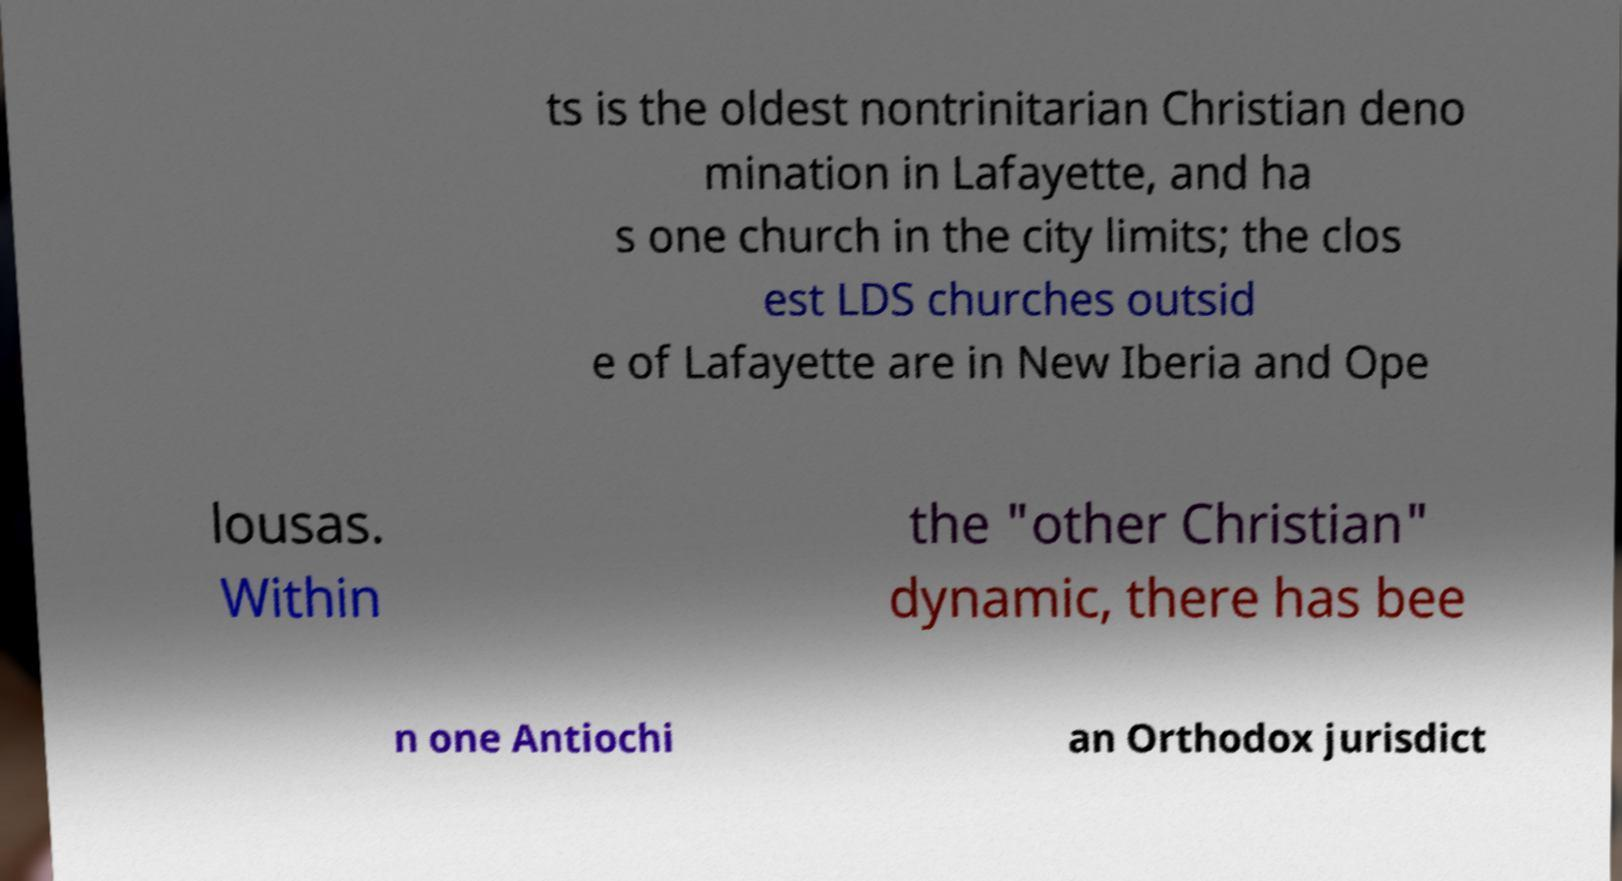For documentation purposes, I need the text within this image transcribed. Could you provide that? ts is the oldest nontrinitarian Christian deno mination in Lafayette, and ha s one church in the city limits; the clos est LDS churches outsid e of Lafayette are in New Iberia and Ope lousas. Within the "other Christian" dynamic, there has bee n one Antiochi an Orthodox jurisdict 